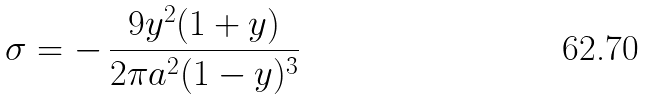<formula> <loc_0><loc_0><loc_500><loc_500>\sigma = - \, \frac { 9 y ^ { 2 } ( 1 + y ) } { 2 \pi a ^ { 2 } ( 1 - y ) ^ { 3 } }</formula> 